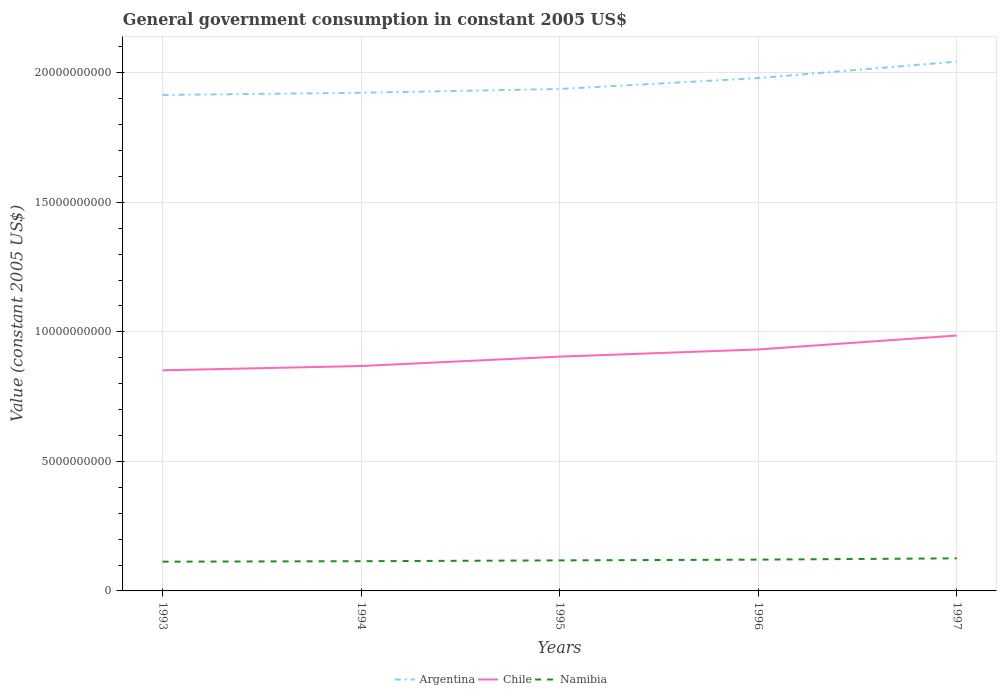How many different coloured lines are there?
Offer a terse response. 3. Across all years, what is the maximum government conusmption in Argentina?
Your answer should be compact. 1.91e+1. In which year was the government conusmption in Chile maximum?
Offer a terse response. 1993. What is the total government conusmption in Chile in the graph?
Offer a terse response. -3.62e+08. What is the difference between the highest and the second highest government conusmption in Argentina?
Your answer should be very brief. 1.29e+09. What is the difference between the highest and the lowest government conusmption in Chile?
Make the answer very short. 2. How many years are there in the graph?
Offer a terse response. 5. Are the values on the major ticks of Y-axis written in scientific E-notation?
Your response must be concise. No. Does the graph contain grids?
Keep it short and to the point. Yes. Where does the legend appear in the graph?
Keep it short and to the point. Bottom center. How are the legend labels stacked?
Ensure brevity in your answer.  Horizontal. What is the title of the graph?
Provide a short and direct response. General government consumption in constant 2005 US$. Does "Belgium" appear as one of the legend labels in the graph?
Provide a short and direct response. No. What is the label or title of the Y-axis?
Give a very brief answer. Value (constant 2005 US$). What is the Value (constant 2005 US$) in Argentina in 1993?
Your response must be concise. 1.91e+1. What is the Value (constant 2005 US$) of Chile in 1993?
Ensure brevity in your answer.  8.52e+09. What is the Value (constant 2005 US$) of Namibia in 1993?
Your answer should be very brief. 1.13e+09. What is the Value (constant 2005 US$) in Argentina in 1994?
Ensure brevity in your answer.  1.92e+1. What is the Value (constant 2005 US$) in Chile in 1994?
Your answer should be very brief. 8.68e+09. What is the Value (constant 2005 US$) in Namibia in 1994?
Your answer should be compact. 1.15e+09. What is the Value (constant 2005 US$) in Argentina in 1995?
Provide a succinct answer. 1.94e+1. What is the Value (constant 2005 US$) of Chile in 1995?
Provide a succinct answer. 9.04e+09. What is the Value (constant 2005 US$) of Namibia in 1995?
Ensure brevity in your answer.  1.18e+09. What is the Value (constant 2005 US$) of Argentina in 1996?
Offer a terse response. 1.98e+1. What is the Value (constant 2005 US$) in Chile in 1996?
Keep it short and to the point. 9.32e+09. What is the Value (constant 2005 US$) of Namibia in 1996?
Give a very brief answer. 1.21e+09. What is the Value (constant 2005 US$) of Argentina in 1997?
Ensure brevity in your answer.  2.04e+1. What is the Value (constant 2005 US$) in Chile in 1997?
Provide a short and direct response. 9.86e+09. What is the Value (constant 2005 US$) in Namibia in 1997?
Provide a short and direct response. 1.26e+09. Across all years, what is the maximum Value (constant 2005 US$) in Argentina?
Offer a very short reply. 2.04e+1. Across all years, what is the maximum Value (constant 2005 US$) in Chile?
Offer a terse response. 9.86e+09. Across all years, what is the maximum Value (constant 2005 US$) in Namibia?
Make the answer very short. 1.26e+09. Across all years, what is the minimum Value (constant 2005 US$) of Argentina?
Provide a short and direct response. 1.91e+1. Across all years, what is the minimum Value (constant 2005 US$) in Chile?
Your response must be concise. 8.52e+09. Across all years, what is the minimum Value (constant 2005 US$) in Namibia?
Offer a terse response. 1.13e+09. What is the total Value (constant 2005 US$) in Argentina in the graph?
Provide a succinct answer. 9.80e+1. What is the total Value (constant 2005 US$) of Chile in the graph?
Provide a succinct answer. 4.54e+1. What is the total Value (constant 2005 US$) in Namibia in the graph?
Make the answer very short. 5.92e+09. What is the difference between the Value (constant 2005 US$) of Argentina in 1993 and that in 1994?
Provide a short and direct response. -8.51e+07. What is the difference between the Value (constant 2005 US$) in Chile in 1993 and that in 1994?
Your answer should be very brief. -1.65e+08. What is the difference between the Value (constant 2005 US$) of Namibia in 1993 and that in 1994?
Give a very brief answer. -1.78e+07. What is the difference between the Value (constant 2005 US$) of Argentina in 1993 and that in 1995?
Make the answer very short. -2.31e+08. What is the difference between the Value (constant 2005 US$) of Chile in 1993 and that in 1995?
Your answer should be compact. -5.27e+08. What is the difference between the Value (constant 2005 US$) in Namibia in 1993 and that in 1995?
Offer a terse response. -4.87e+07. What is the difference between the Value (constant 2005 US$) in Argentina in 1993 and that in 1996?
Make the answer very short. -6.52e+08. What is the difference between the Value (constant 2005 US$) of Chile in 1993 and that in 1996?
Provide a short and direct response. -8.04e+08. What is the difference between the Value (constant 2005 US$) in Namibia in 1993 and that in 1996?
Offer a very short reply. -7.93e+07. What is the difference between the Value (constant 2005 US$) in Argentina in 1993 and that in 1997?
Make the answer very short. -1.29e+09. What is the difference between the Value (constant 2005 US$) of Chile in 1993 and that in 1997?
Your response must be concise. -1.34e+09. What is the difference between the Value (constant 2005 US$) of Namibia in 1993 and that in 1997?
Your answer should be very brief. -1.28e+08. What is the difference between the Value (constant 2005 US$) in Argentina in 1994 and that in 1995?
Give a very brief answer. -1.46e+08. What is the difference between the Value (constant 2005 US$) of Chile in 1994 and that in 1995?
Your answer should be compact. -3.62e+08. What is the difference between the Value (constant 2005 US$) of Namibia in 1994 and that in 1995?
Give a very brief answer. -3.09e+07. What is the difference between the Value (constant 2005 US$) of Argentina in 1994 and that in 1996?
Provide a succinct answer. -5.67e+08. What is the difference between the Value (constant 2005 US$) in Chile in 1994 and that in 1996?
Provide a succinct answer. -6.39e+08. What is the difference between the Value (constant 2005 US$) of Namibia in 1994 and that in 1996?
Your response must be concise. -6.15e+07. What is the difference between the Value (constant 2005 US$) of Argentina in 1994 and that in 1997?
Give a very brief answer. -1.20e+09. What is the difference between the Value (constant 2005 US$) of Chile in 1994 and that in 1997?
Ensure brevity in your answer.  -1.18e+09. What is the difference between the Value (constant 2005 US$) of Namibia in 1994 and that in 1997?
Your response must be concise. -1.10e+08. What is the difference between the Value (constant 2005 US$) of Argentina in 1995 and that in 1996?
Offer a very short reply. -4.20e+08. What is the difference between the Value (constant 2005 US$) of Chile in 1995 and that in 1996?
Offer a very short reply. -2.76e+08. What is the difference between the Value (constant 2005 US$) of Namibia in 1995 and that in 1996?
Provide a succinct answer. -3.06e+07. What is the difference between the Value (constant 2005 US$) of Argentina in 1995 and that in 1997?
Offer a terse response. -1.06e+09. What is the difference between the Value (constant 2005 US$) in Chile in 1995 and that in 1997?
Keep it short and to the point. -8.14e+08. What is the difference between the Value (constant 2005 US$) of Namibia in 1995 and that in 1997?
Your answer should be very brief. -7.93e+07. What is the difference between the Value (constant 2005 US$) in Argentina in 1996 and that in 1997?
Your answer should be compact. -6.37e+08. What is the difference between the Value (constant 2005 US$) in Chile in 1996 and that in 1997?
Offer a very short reply. -5.38e+08. What is the difference between the Value (constant 2005 US$) in Namibia in 1996 and that in 1997?
Make the answer very short. -4.88e+07. What is the difference between the Value (constant 2005 US$) in Argentina in 1993 and the Value (constant 2005 US$) in Chile in 1994?
Keep it short and to the point. 1.05e+1. What is the difference between the Value (constant 2005 US$) of Argentina in 1993 and the Value (constant 2005 US$) of Namibia in 1994?
Provide a short and direct response. 1.80e+1. What is the difference between the Value (constant 2005 US$) of Chile in 1993 and the Value (constant 2005 US$) of Namibia in 1994?
Ensure brevity in your answer.  7.37e+09. What is the difference between the Value (constant 2005 US$) of Argentina in 1993 and the Value (constant 2005 US$) of Chile in 1995?
Provide a short and direct response. 1.01e+1. What is the difference between the Value (constant 2005 US$) in Argentina in 1993 and the Value (constant 2005 US$) in Namibia in 1995?
Your answer should be compact. 1.80e+1. What is the difference between the Value (constant 2005 US$) of Chile in 1993 and the Value (constant 2005 US$) of Namibia in 1995?
Your response must be concise. 7.34e+09. What is the difference between the Value (constant 2005 US$) of Argentina in 1993 and the Value (constant 2005 US$) of Chile in 1996?
Offer a very short reply. 9.82e+09. What is the difference between the Value (constant 2005 US$) of Argentina in 1993 and the Value (constant 2005 US$) of Namibia in 1996?
Provide a short and direct response. 1.79e+1. What is the difference between the Value (constant 2005 US$) in Chile in 1993 and the Value (constant 2005 US$) in Namibia in 1996?
Your response must be concise. 7.31e+09. What is the difference between the Value (constant 2005 US$) in Argentina in 1993 and the Value (constant 2005 US$) in Chile in 1997?
Provide a short and direct response. 9.29e+09. What is the difference between the Value (constant 2005 US$) in Argentina in 1993 and the Value (constant 2005 US$) in Namibia in 1997?
Your response must be concise. 1.79e+1. What is the difference between the Value (constant 2005 US$) in Chile in 1993 and the Value (constant 2005 US$) in Namibia in 1997?
Give a very brief answer. 7.26e+09. What is the difference between the Value (constant 2005 US$) of Argentina in 1994 and the Value (constant 2005 US$) of Chile in 1995?
Keep it short and to the point. 1.02e+1. What is the difference between the Value (constant 2005 US$) in Argentina in 1994 and the Value (constant 2005 US$) in Namibia in 1995?
Offer a terse response. 1.81e+1. What is the difference between the Value (constant 2005 US$) of Chile in 1994 and the Value (constant 2005 US$) of Namibia in 1995?
Make the answer very short. 7.50e+09. What is the difference between the Value (constant 2005 US$) of Argentina in 1994 and the Value (constant 2005 US$) of Chile in 1996?
Ensure brevity in your answer.  9.91e+09. What is the difference between the Value (constant 2005 US$) of Argentina in 1994 and the Value (constant 2005 US$) of Namibia in 1996?
Your answer should be compact. 1.80e+1. What is the difference between the Value (constant 2005 US$) of Chile in 1994 and the Value (constant 2005 US$) of Namibia in 1996?
Your answer should be very brief. 7.47e+09. What is the difference between the Value (constant 2005 US$) of Argentina in 1994 and the Value (constant 2005 US$) of Chile in 1997?
Provide a succinct answer. 9.37e+09. What is the difference between the Value (constant 2005 US$) in Argentina in 1994 and the Value (constant 2005 US$) in Namibia in 1997?
Your answer should be compact. 1.80e+1. What is the difference between the Value (constant 2005 US$) in Chile in 1994 and the Value (constant 2005 US$) in Namibia in 1997?
Offer a terse response. 7.42e+09. What is the difference between the Value (constant 2005 US$) in Argentina in 1995 and the Value (constant 2005 US$) in Chile in 1996?
Provide a succinct answer. 1.01e+1. What is the difference between the Value (constant 2005 US$) in Argentina in 1995 and the Value (constant 2005 US$) in Namibia in 1996?
Provide a short and direct response. 1.82e+1. What is the difference between the Value (constant 2005 US$) of Chile in 1995 and the Value (constant 2005 US$) of Namibia in 1996?
Provide a succinct answer. 7.83e+09. What is the difference between the Value (constant 2005 US$) of Argentina in 1995 and the Value (constant 2005 US$) of Chile in 1997?
Ensure brevity in your answer.  9.52e+09. What is the difference between the Value (constant 2005 US$) of Argentina in 1995 and the Value (constant 2005 US$) of Namibia in 1997?
Make the answer very short. 1.81e+1. What is the difference between the Value (constant 2005 US$) of Chile in 1995 and the Value (constant 2005 US$) of Namibia in 1997?
Provide a short and direct response. 7.79e+09. What is the difference between the Value (constant 2005 US$) in Argentina in 1996 and the Value (constant 2005 US$) in Chile in 1997?
Offer a very short reply. 9.94e+09. What is the difference between the Value (constant 2005 US$) of Argentina in 1996 and the Value (constant 2005 US$) of Namibia in 1997?
Your answer should be very brief. 1.85e+1. What is the difference between the Value (constant 2005 US$) of Chile in 1996 and the Value (constant 2005 US$) of Namibia in 1997?
Your answer should be very brief. 8.06e+09. What is the average Value (constant 2005 US$) of Argentina per year?
Your answer should be very brief. 1.96e+1. What is the average Value (constant 2005 US$) in Chile per year?
Your answer should be very brief. 9.08e+09. What is the average Value (constant 2005 US$) of Namibia per year?
Make the answer very short. 1.18e+09. In the year 1993, what is the difference between the Value (constant 2005 US$) of Argentina and Value (constant 2005 US$) of Chile?
Give a very brief answer. 1.06e+1. In the year 1993, what is the difference between the Value (constant 2005 US$) of Argentina and Value (constant 2005 US$) of Namibia?
Your answer should be very brief. 1.80e+1. In the year 1993, what is the difference between the Value (constant 2005 US$) in Chile and Value (constant 2005 US$) in Namibia?
Give a very brief answer. 7.39e+09. In the year 1994, what is the difference between the Value (constant 2005 US$) in Argentina and Value (constant 2005 US$) in Chile?
Offer a terse response. 1.05e+1. In the year 1994, what is the difference between the Value (constant 2005 US$) of Argentina and Value (constant 2005 US$) of Namibia?
Your response must be concise. 1.81e+1. In the year 1994, what is the difference between the Value (constant 2005 US$) in Chile and Value (constant 2005 US$) in Namibia?
Provide a short and direct response. 7.53e+09. In the year 1995, what is the difference between the Value (constant 2005 US$) of Argentina and Value (constant 2005 US$) of Chile?
Your response must be concise. 1.03e+1. In the year 1995, what is the difference between the Value (constant 2005 US$) of Argentina and Value (constant 2005 US$) of Namibia?
Provide a short and direct response. 1.82e+1. In the year 1995, what is the difference between the Value (constant 2005 US$) in Chile and Value (constant 2005 US$) in Namibia?
Ensure brevity in your answer.  7.87e+09. In the year 1996, what is the difference between the Value (constant 2005 US$) of Argentina and Value (constant 2005 US$) of Chile?
Keep it short and to the point. 1.05e+1. In the year 1996, what is the difference between the Value (constant 2005 US$) of Argentina and Value (constant 2005 US$) of Namibia?
Your response must be concise. 1.86e+1. In the year 1996, what is the difference between the Value (constant 2005 US$) of Chile and Value (constant 2005 US$) of Namibia?
Offer a very short reply. 8.11e+09. In the year 1997, what is the difference between the Value (constant 2005 US$) of Argentina and Value (constant 2005 US$) of Chile?
Offer a very short reply. 1.06e+1. In the year 1997, what is the difference between the Value (constant 2005 US$) of Argentina and Value (constant 2005 US$) of Namibia?
Offer a very short reply. 1.92e+1. In the year 1997, what is the difference between the Value (constant 2005 US$) of Chile and Value (constant 2005 US$) of Namibia?
Your answer should be compact. 8.60e+09. What is the ratio of the Value (constant 2005 US$) of Argentina in 1993 to that in 1994?
Make the answer very short. 1. What is the ratio of the Value (constant 2005 US$) in Chile in 1993 to that in 1994?
Your response must be concise. 0.98. What is the ratio of the Value (constant 2005 US$) of Namibia in 1993 to that in 1994?
Your response must be concise. 0.98. What is the ratio of the Value (constant 2005 US$) of Argentina in 1993 to that in 1995?
Offer a terse response. 0.99. What is the ratio of the Value (constant 2005 US$) of Chile in 1993 to that in 1995?
Provide a short and direct response. 0.94. What is the ratio of the Value (constant 2005 US$) of Namibia in 1993 to that in 1995?
Your answer should be very brief. 0.96. What is the ratio of the Value (constant 2005 US$) in Argentina in 1993 to that in 1996?
Make the answer very short. 0.97. What is the ratio of the Value (constant 2005 US$) in Chile in 1993 to that in 1996?
Keep it short and to the point. 0.91. What is the ratio of the Value (constant 2005 US$) of Namibia in 1993 to that in 1996?
Ensure brevity in your answer.  0.93. What is the ratio of the Value (constant 2005 US$) of Argentina in 1993 to that in 1997?
Ensure brevity in your answer.  0.94. What is the ratio of the Value (constant 2005 US$) in Chile in 1993 to that in 1997?
Provide a short and direct response. 0.86. What is the ratio of the Value (constant 2005 US$) in Namibia in 1993 to that in 1997?
Your response must be concise. 0.9. What is the ratio of the Value (constant 2005 US$) of Argentina in 1994 to that in 1995?
Provide a succinct answer. 0.99. What is the ratio of the Value (constant 2005 US$) of Chile in 1994 to that in 1995?
Ensure brevity in your answer.  0.96. What is the ratio of the Value (constant 2005 US$) of Namibia in 1994 to that in 1995?
Your answer should be compact. 0.97. What is the ratio of the Value (constant 2005 US$) of Argentina in 1994 to that in 1996?
Provide a succinct answer. 0.97. What is the ratio of the Value (constant 2005 US$) in Chile in 1994 to that in 1996?
Give a very brief answer. 0.93. What is the ratio of the Value (constant 2005 US$) in Namibia in 1994 to that in 1996?
Your answer should be very brief. 0.95. What is the ratio of the Value (constant 2005 US$) of Argentina in 1994 to that in 1997?
Offer a terse response. 0.94. What is the ratio of the Value (constant 2005 US$) of Chile in 1994 to that in 1997?
Your answer should be compact. 0.88. What is the ratio of the Value (constant 2005 US$) of Namibia in 1994 to that in 1997?
Make the answer very short. 0.91. What is the ratio of the Value (constant 2005 US$) of Argentina in 1995 to that in 1996?
Your answer should be compact. 0.98. What is the ratio of the Value (constant 2005 US$) in Chile in 1995 to that in 1996?
Provide a succinct answer. 0.97. What is the ratio of the Value (constant 2005 US$) in Namibia in 1995 to that in 1996?
Your answer should be compact. 0.97. What is the ratio of the Value (constant 2005 US$) in Argentina in 1995 to that in 1997?
Make the answer very short. 0.95. What is the ratio of the Value (constant 2005 US$) of Chile in 1995 to that in 1997?
Keep it short and to the point. 0.92. What is the ratio of the Value (constant 2005 US$) of Namibia in 1995 to that in 1997?
Give a very brief answer. 0.94. What is the ratio of the Value (constant 2005 US$) of Argentina in 1996 to that in 1997?
Your response must be concise. 0.97. What is the ratio of the Value (constant 2005 US$) of Chile in 1996 to that in 1997?
Your answer should be compact. 0.95. What is the ratio of the Value (constant 2005 US$) of Namibia in 1996 to that in 1997?
Your answer should be compact. 0.96. What is the difference between the highest and the second highest Value (constant 2005 US$) of Argentina?
Ensure brevity in your answer.  6.37e+08. What is the difference between the highest and the second highest Value (constant 2005 US$) of Chile?
Your answer should be very brief. 5.38e+08. What is the difference between the highest and the second highest Value (constant 2005 US$) in Namibia?
Ensure brevity in your answer.  4.88e+07. What is the difference between the highest and the lowest Value (constant 2005 US$) of Argentina?
Offer a terse response. 1.29e+09. What is the difference between the highest and the lowest Value (constant 2005 US$) of Chile?
Provide a succinct answer. 1.34e+09. What is the difference between the highest and the lowest Value (constant 2005 US$) in Namibia?
Offer a very short reply. 1.28e+08. 